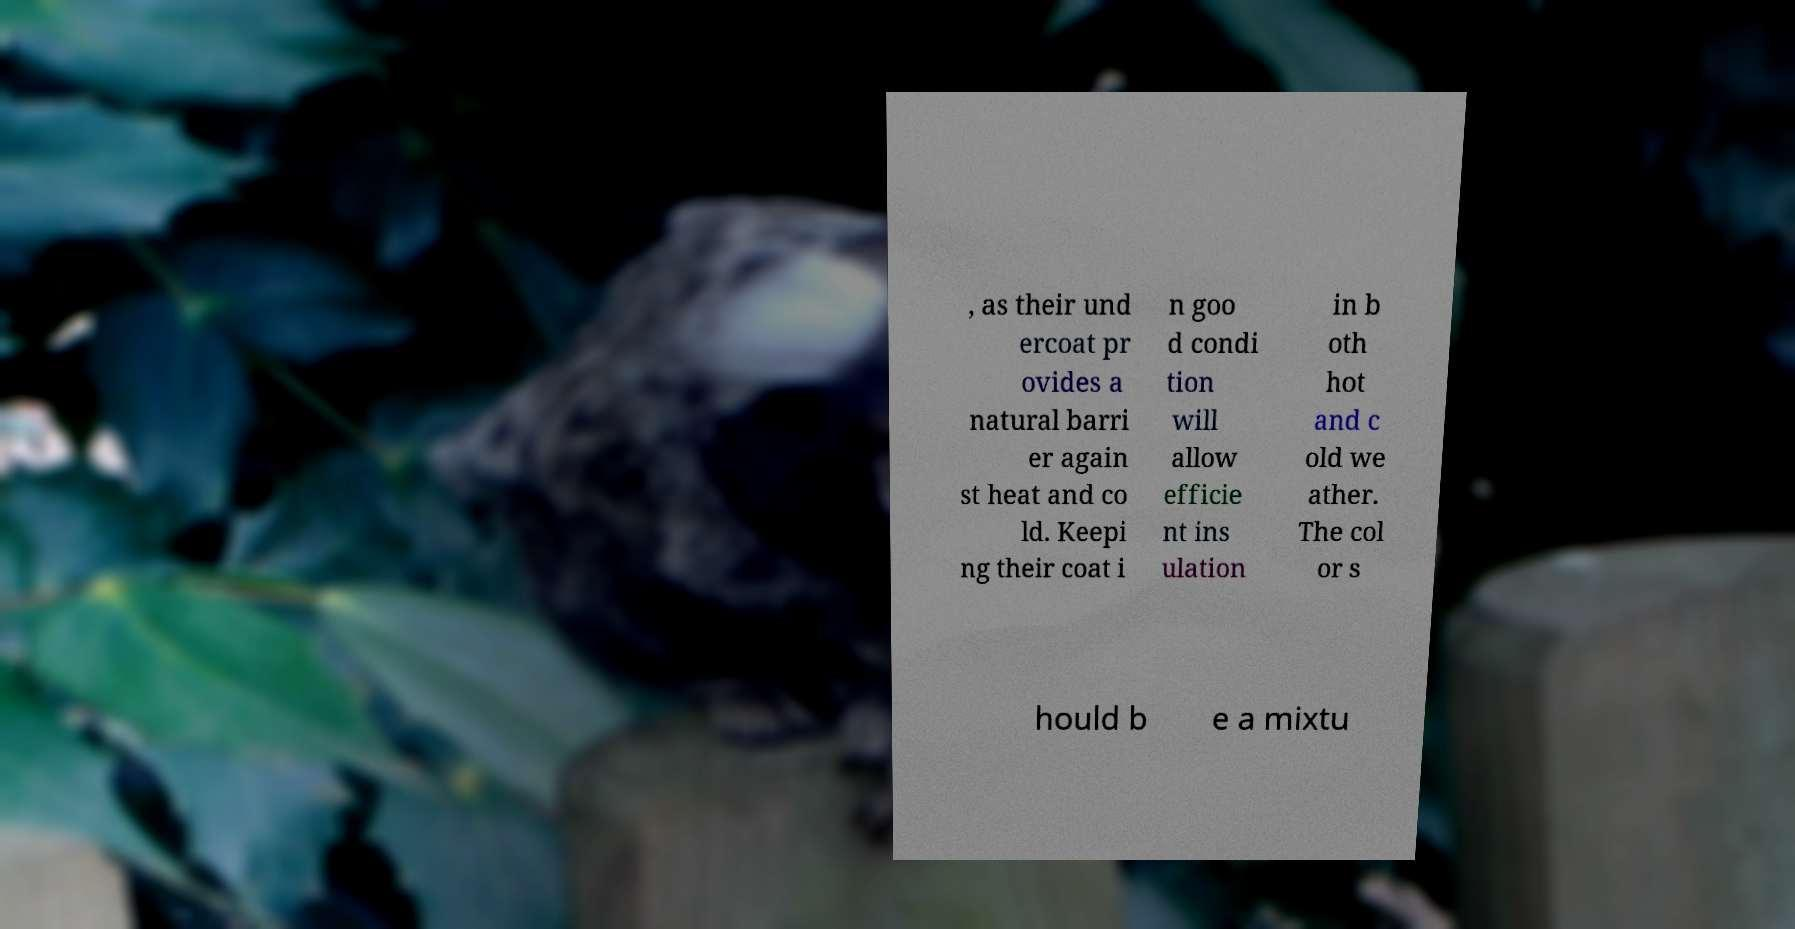Can you read and provide the text displayed in the image?This photo seems to have some interesting text. Can you extract and type it out for me? , as their und ercoat pr ovides a natural barri er again st heat and co ld. Keepi ng their coat i n goo d condi tion will allow efficie nt ins ulation in b oth hot and c old we ather. The col or s hould b e a mixtu 